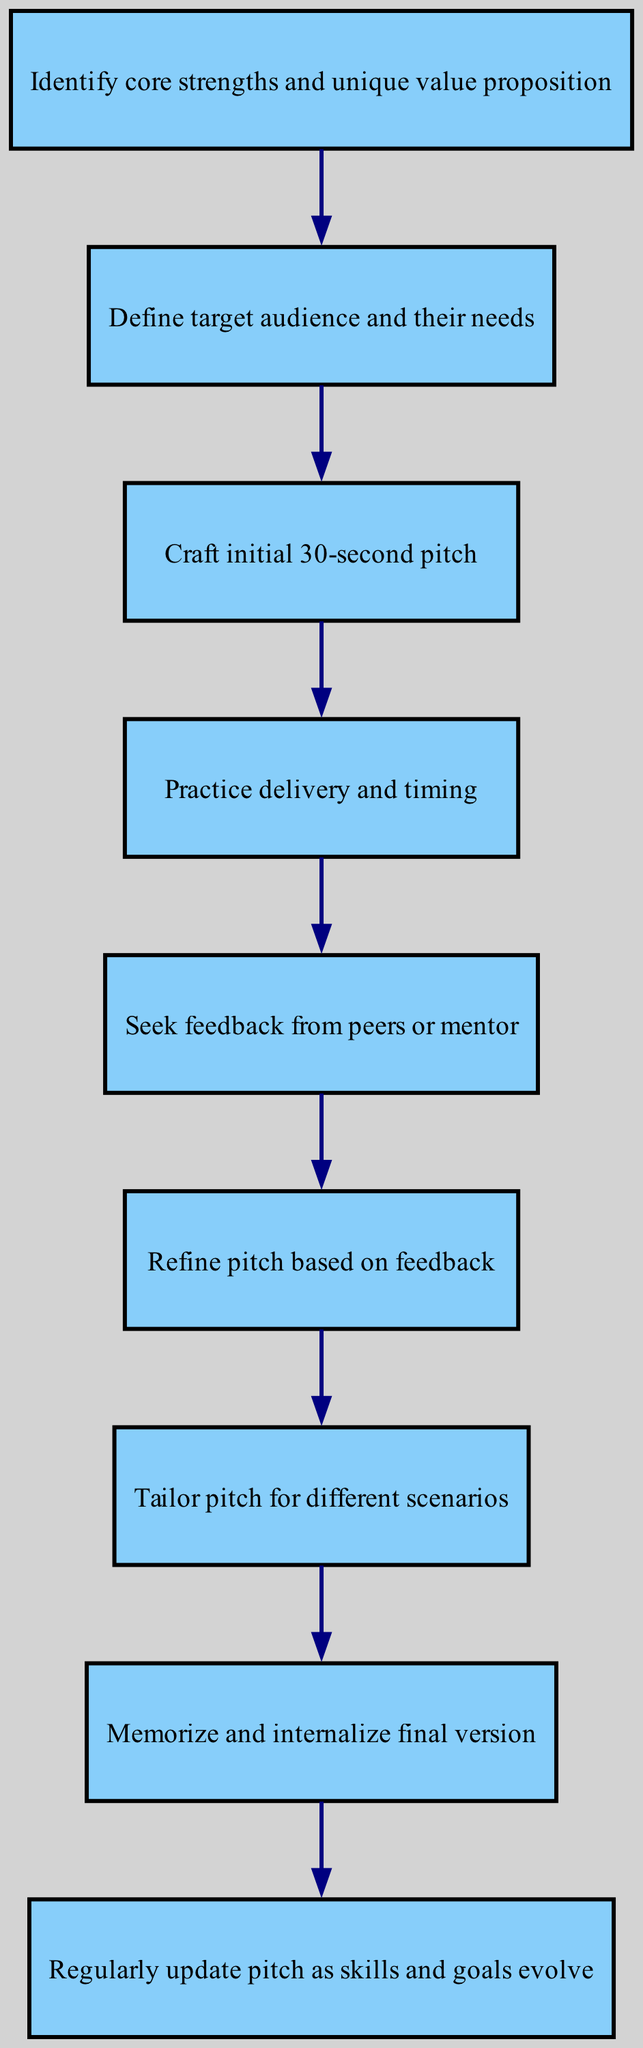What is the first step in developing a personalized elevator pitch? The first step is to identify core strengths and unique value proposition, as indicated by the first node in the diagram.
Answer: Identify core strengths and unique value proposition How many total nodes are present in the diagram? The diagram consists of 9 nodes, each representing a specific step in the process of developing a personalized elevator pitch.
Answer: 9 What is the last step outlined in the diagram? The last step is to regularly update the pitch as skills and goals evolve, shown in the ninth node of the diagram.
Answer: Regularly update pitch as skills and goals evolve What step follows after seeking feedback from peers or mentor? After seeking feedback, the next step is to refine the pitch based on feedback, which is the sixth node that follows the fifth node in the flowchart.
Answer: Refine pitch based on feedback Which two steps are directly connected to the node that involves crafting an initial 30-second pitch? The steps directly connected to crafting an initial 30-second pitch are defining the target audience and their needs, which precedes it, and practicing delivery and timing, which follows it.
Answer: Define target audience and their needs; Practice delivery and timing How many edges are there in the diagram? There are 8 edges in the diagram, as indicated by the connections between the various steps or nodes outlined in the process.
Answer: 8 Which step involves tailoring the elevator pitch for different scenarios? The fifth step in the diagram entails tailoring the pitch for different scenarios, connected from the refining step and leading to the memorization phase.
Answer: Tailor pitch for different scenarios What step comes before memorizing and internalizing the final version of the pitch? Before memorizing and internalizing, the step is to tailor the pitch for different scenarios, indicating the preparation for delivery.
Answer: Tailor pitch for different scenarios 